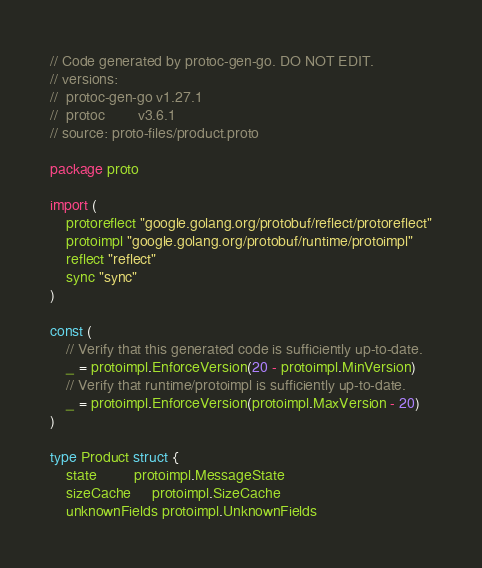Convert code to text. <code><loc_0><loc_0><loc_500><loc_500><_Go_>// Code generated by protoc-gen-go. DO NOT EDIT.
// versions:
// 	protoc-gen-go v1.27.1
// 	protoc        v3.6.1
// source: proto-files/product.proto

package proto

import (
	protoreflect "google.golang.org/protobuf/reflect/protoreflect"
	protoimpl "google.golang.org/protobuf/runtime/protoimpl"
	reflect "reflect"
	sync "sync"
)

const (
	// Verify that this generated code is sufficiently up-to-date.
	_ = protoimpl.EnforceVersion(20 - protoimpl.MinVersion)
	// Verify that runtime/protoimpl is sufficiently up-to-date.
	_ = protoimpl.EnforceVersion(protoimpl.MaxVersion - 20)
)

type Product struct {
	state         protoimpl.MessageState
	sizeCache     protoimpl.SizeCache
	unknownFields protoimpl.UnknownFields
</code> 